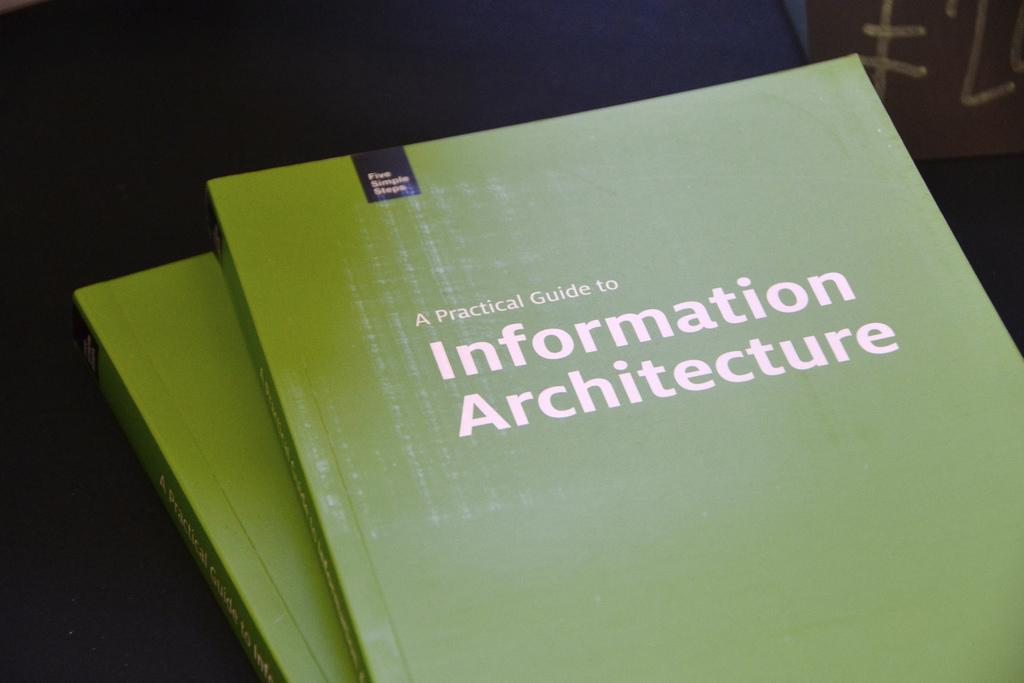<image>
Present a compact description of the photo's key features. two green A Practical Guide to Information Architecture on a table 